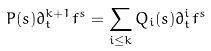Convert formula to latex. <formula><loc_0><loc_0><loc_500><loc_500>P ( s ) \partial _ { t } ^ { k + 1 } f ^ { s } = \sum _ { i \leq k } Q _ { i } ( s ) \partial _ { t } ^ { i } f ^ { s }</formula> 